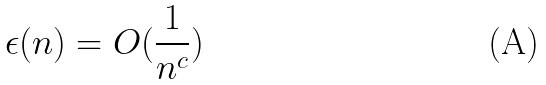<formula> <loc_0><loc_0><loc_500><loc_500>\epsilon ( n ) = O ( \frac { 1 } { n ^ { c } } )</formula> 